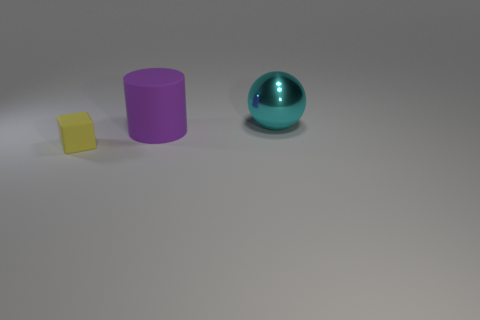Add 1 big purple rubber objects. How many objects exist? 4 Subtract all cylinders. How many objects are left? 2 Add 1 cyan spheres. How many cyan spheres are left? 2 Add 3 objects. How many objects exist? 6 Subtract 0 cyan blocks. How many objects are left? 3 Subtract all yellow cylinders. Subtract all brown blocks. How many cylinders are left? 1 Subtract all tiny yellow matte things. Subtract all small matte things. How many objects are left? 1 